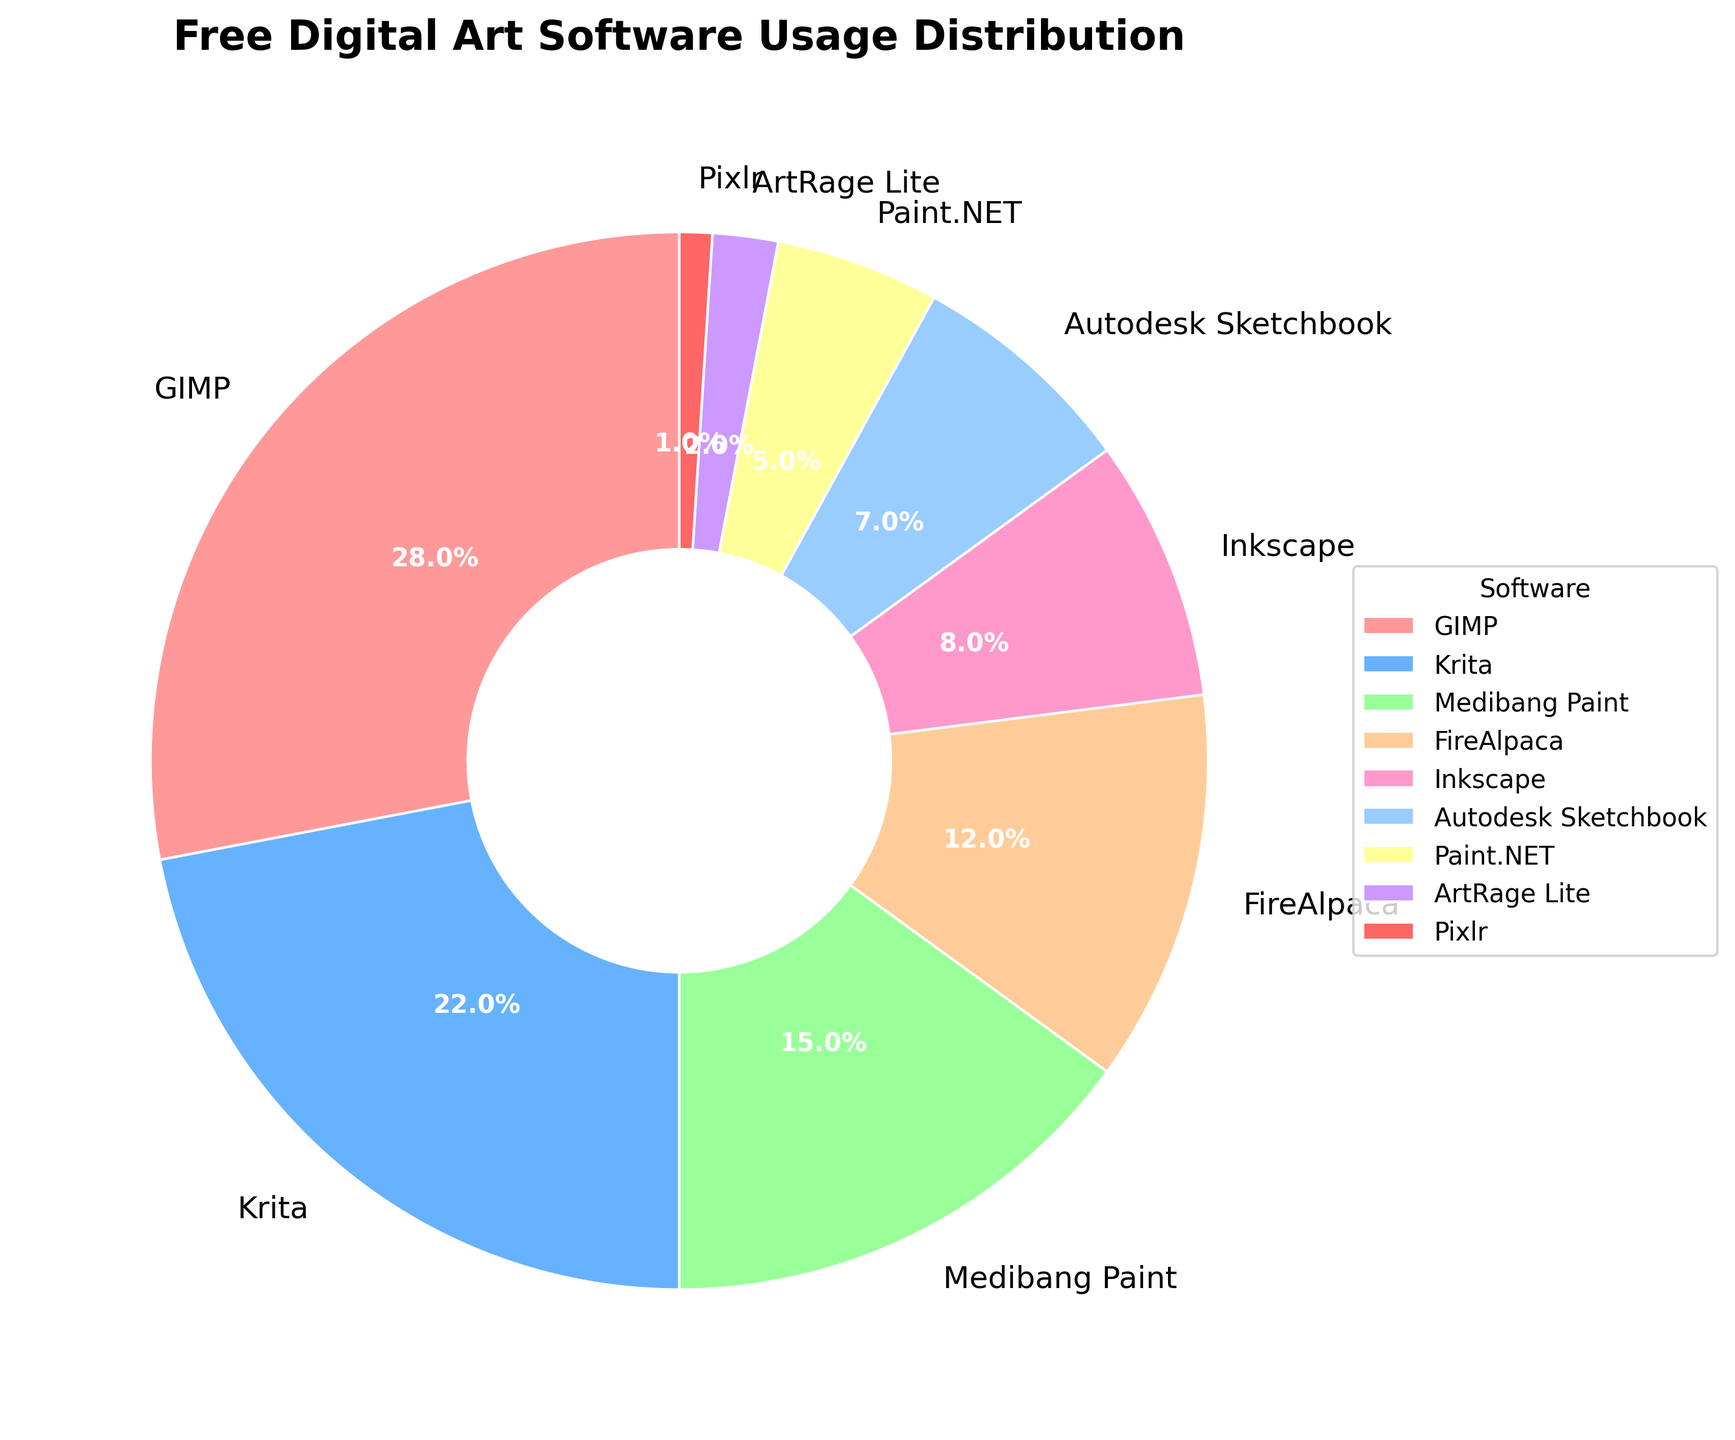Which software has the largest usage percentage? Locate the largest wedge in the pie chart. The label on that wedge should be "GIMP" with 28%.
Answer: GIMP What is the combined usage percentage of Medibang Paint and FireAlpaca? Find the percentages for Medibang Paint (15%) and FireAlpaca (12%). Add them together: 15% + 12% = 27%.
Answer: 27% Is the percentage of Paint.NET usage greater than that of Autodesk Sketchbook? Paint.NET has 5%, and Autodesk Sketchbook has 7%. Since 5% < 7%, Paint.NET is not greater.
Answer: No Which software has the smallest usage percentage? Identify the smallest wedge on the pie chart. The label on that wedge should be "Pixlr" with 1%.
Answer: Pixlr How many software have a usage percentage of less than 10%? Identify slices with a value below 10%. Inkscape (8%), Autodesk Sketchbook (7%), Paint.NET (5%), ArtRage Lite (2%), Pixlr (1%) give a total of 5.
Answer: 5 What is the percentage difference between the usage of Krita and Inkscape? Locate Krita (22%) and Inkscape (8%). Subtract the percentages: 22% - 8% = 14%.
Answer: 14% Which software has more usage, Medibang Paint or Krita? Compare the usage percentages: Medibang Paint (15%) and Krita (22%). Since 22% > 15%, Krita has more usage.
Answer: Krita What percentage of usage do the top three software combined account for? Find the top three percentages: GIMP (28%), Krita (22%), Medibang Paint (15%). Sum them: 28% + 22% + 15% = 65%.
Answer: 65% Are there any software with a usage percentage exactly equal to 10%? Review each percentage but see that none is precisely 10%.
Answer: No What is the difference in usage percentage between the highest (GIMP) and lowest (Pixlr) software? Identify the highest (GIMP, 28%) and lowest (Pixlr, 1%). Subtract: 28% - 1% = 27%.
Answer: 27% 